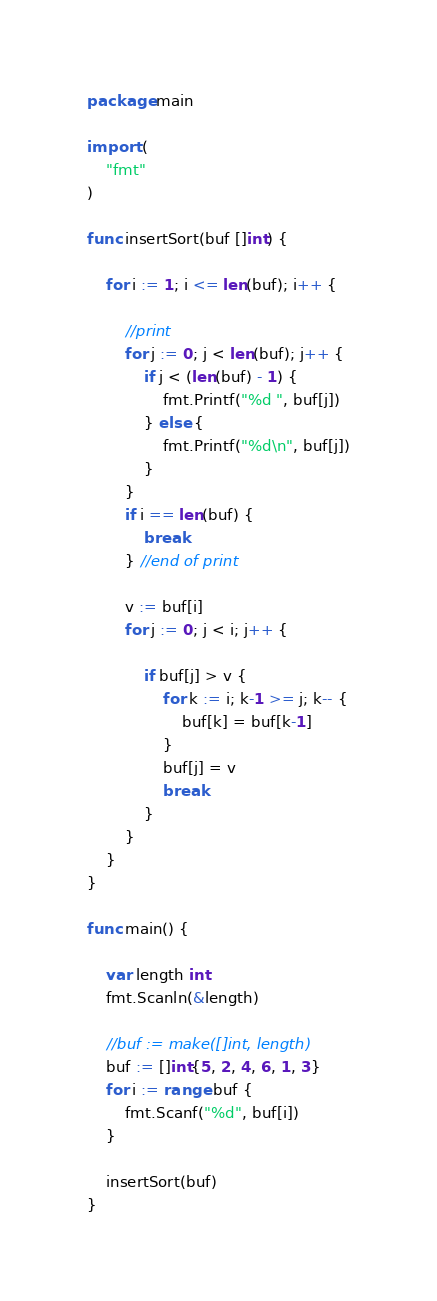Convert code to text. <code><loc_0><loc_0><loc_500><loc_500><_Go_>package main

import (
	"fmt"
)

func insertSort(buf []int) {

	for i := 1; i <= len(buf); i++ {

		//print
		for j := 0; j < len(buf); j++ {
			if j < (len(buf) - 1) {
				fmt.Printf("%d ", buf[j])
			} else {
				fmt.Printf("%d\n", buf[j])
			}
		}
		if i == len(buf) {
			break
		} //end of print

		v := buf[i]
		for j := 0; j < i; j++ {

			if buf[j] > v {
				for k := i; k-1 >= j; k-- {
					buf[k] = buf[k-1]
				}
				buf[j] = v
				break
			}
		}
	}
}

func main() {

	var length int
	fmt.Scanln(&length)

	//buf := make([]int, length)
	buf := []int{5, 2, 4, 6, 1, 3}
	for i := range buf {
		fmt.Scanf("%d", buf[i])
	}

	insertSort(buf)
}

</code> 